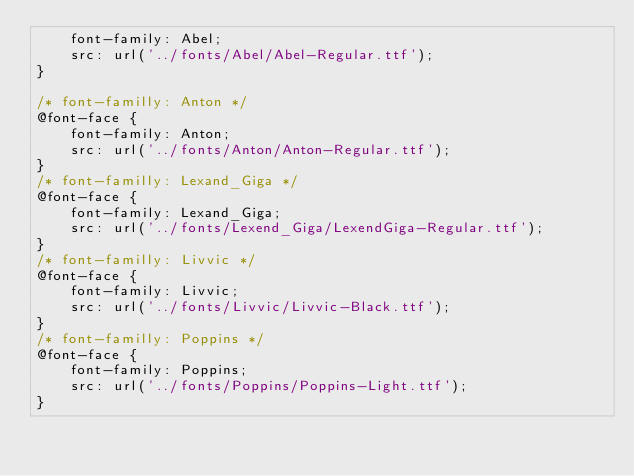<code> <loc_0><loc_0><loc_500><loc_500><_CSS_>    font-family: Abel;
    src: url('../fonts/Abel/Abel-Regular.ttf');
}

/* font-familly: Anton */ 
@font-face {
    font-family: Anton;
    src: url('../fonts/Anton/Anton-Regular.ttf');
}
/* font-familly: Lexand_Giga */ 
@font-face {
    font-family: Lexand_Giga;
    src: url('../fonts/Lexend_Giga/LexendGiga-Regular.ttf');
}
/* font-familly: Livvic */ 
@font-face {
    font-family: Livvic;
    src: url('../fonts/Livvic/Livvic-Black.ttf');
}
/* font-familly: Poppins */ 
@font-face {
    font-family: Poppins;
    src: url('../fonts/Poppins/Poppins-Light.ttf');
}

</code> 